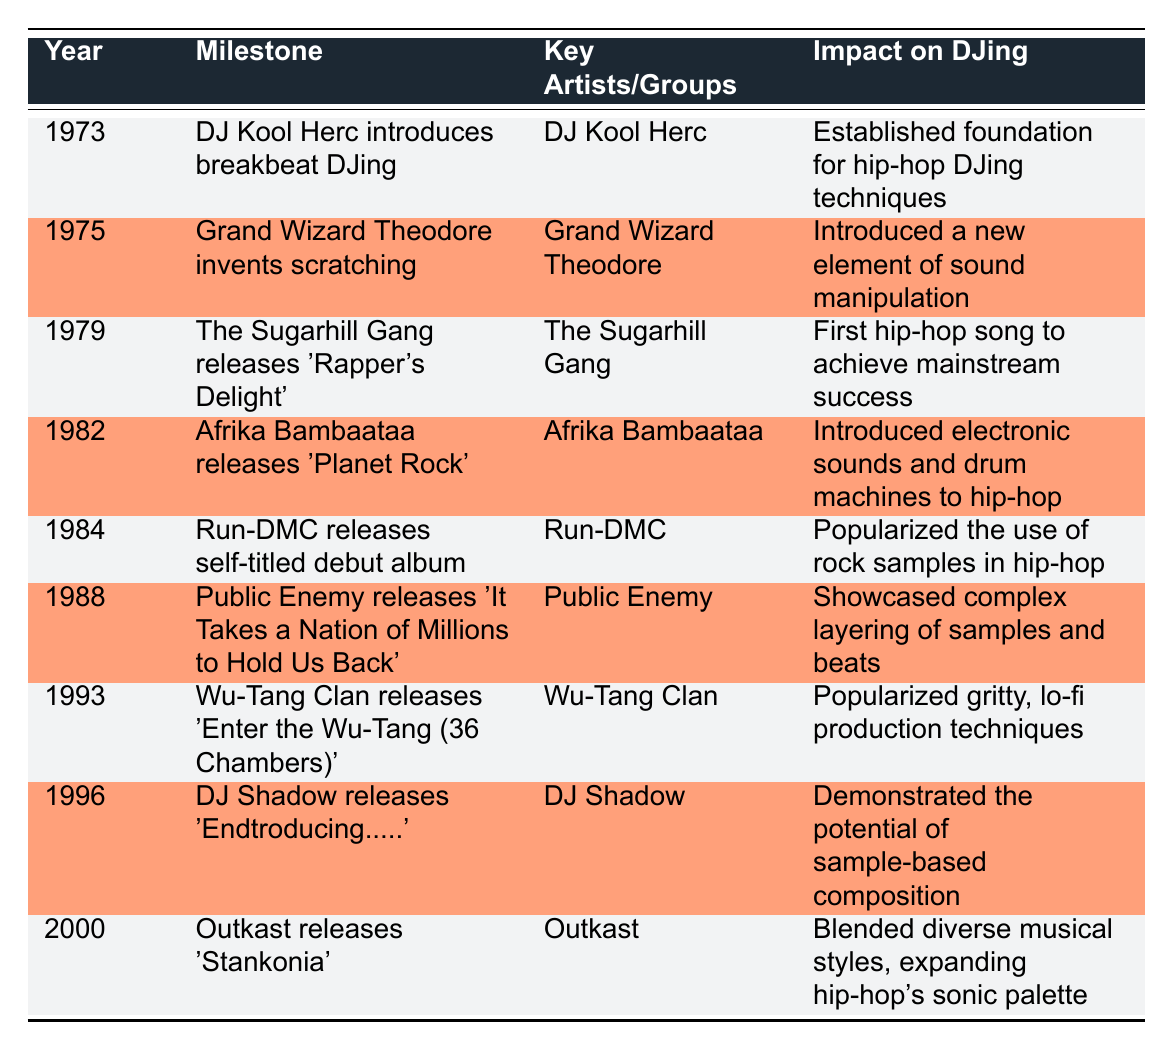What milestone did DJ Kool Herc introduce in 1973? The table indicates that in 1973, DJ Kool Herc introduced breakbeat DJing, which was a foundational technique for hip-hop DJing.
Answer: DJ Kool Herc introduced breakbeat DJing Which artist is associated with the release of "Planet Rock"? According to the table, Afrika Bambaataa is the key artist associated with the release of "Planet Rock" in 1982.
Answer: Afrika Bambaataa In what year did Public Enemy release "It Takes a Nation of Millions to Hold Us Back"? The table shows that Public Enemy released this album in 1988.
Answer: 1988 Did the Sugarhill Gang achieve mainstream success with "Rapper's Delight"? Yes, the table states that "Rapper's Delight" was the first hip-hop song to achieve mainstream success, which confirms that the Sugarhill Gang had this achievement.
Answer: Yes What is the impact of Wu-Tang Clan's "Enter the Wu-Tang (36 Chambers)" on DJing compared to the album by Outkast released in 2000? The table details that Wu-Tang Clan popularized gritty, lo-fi production techniques, while Outkast blended diverse musical styles, expanding hip-hop's sonic palette. Therefore, both contributed uniquely, with Wu-Tang focusing on gritty sound and Outkast on diversity.
Answer: They both had unique impacts; Wu-Tang on gritty sound and Outkast on diversity 